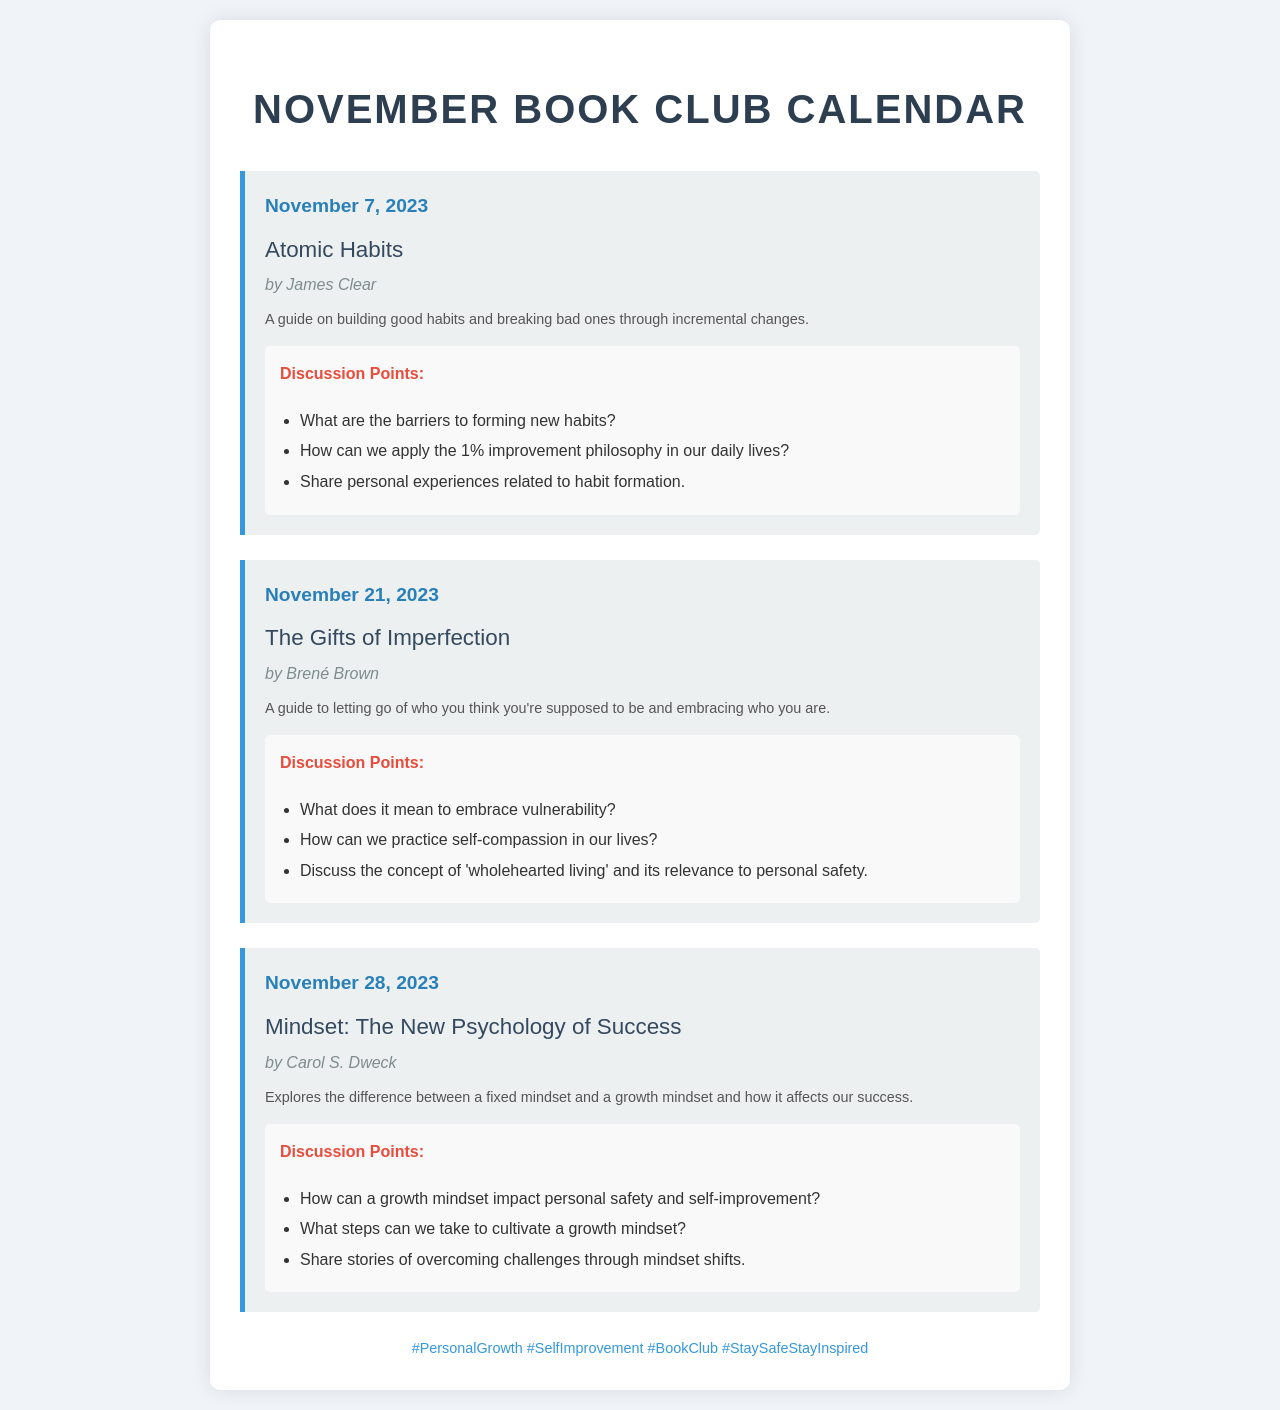What is the date of the first meeting? The first meeting is scheduled on November 7, 2023.
Answer: November 7, 2023 Who is the author of "Mindset: The New Psychology of Success"? The author of the book is mentioned in the document as Carol S. Dweck.
Answer: Carol S. Dweck What is the main theme of "The Gifts of Imperfection"? The document summarizes it as a guide to embracing who you are.
Answer: Embracing who you are How many books are selected for the November Book Club? The document lists three different books for the month.
Answer: Three What are the discussion points for "Atomic Habits"? The document outlines specific discussion points related to habit formation.
Answer: Barriers to forming new habits, apply 1% improvement, personal experiences Which book focuses on the concept of a growth mindset? The document highlights "Mindset: The New Psychology of Success" as focusing on this concept.
Answer: Mindset: The New Psychology of Success What color is used for the date section in the meetings? The style specifies that the date is in bold and blue color.
Answer: Blue What is the last meeting date listed in the document? The last meeting is scheduled for November 28, 2023.
Answer: November 28, 2023 